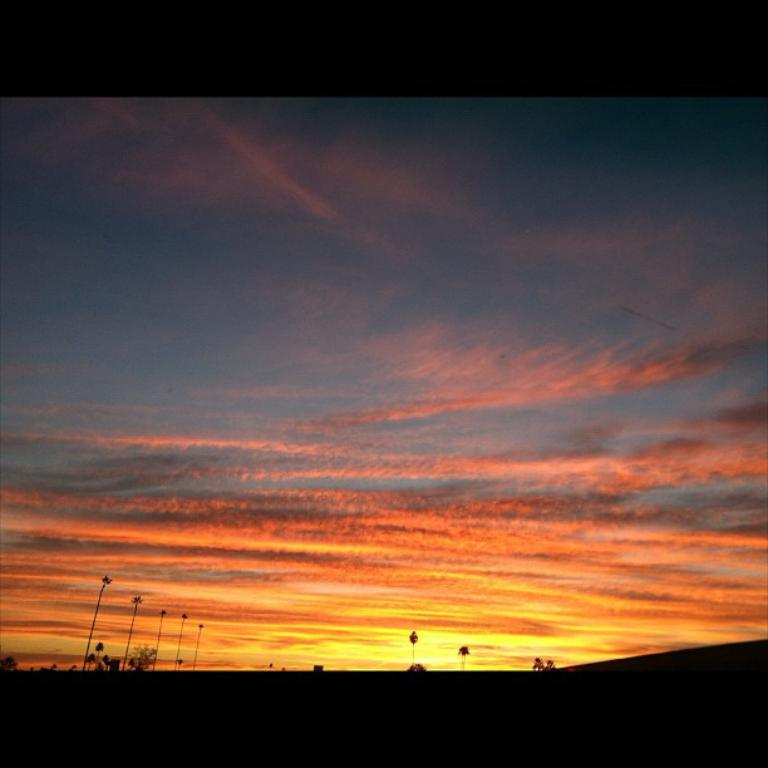What type of natural elements can be seen in the image? There are trees in the image. What part of the natural environment is visible in the image? The sky is visible in the background of the image. What type of book is being used as a pail in the image? There is no book or pail present in the image; it only features trees and the sky. 